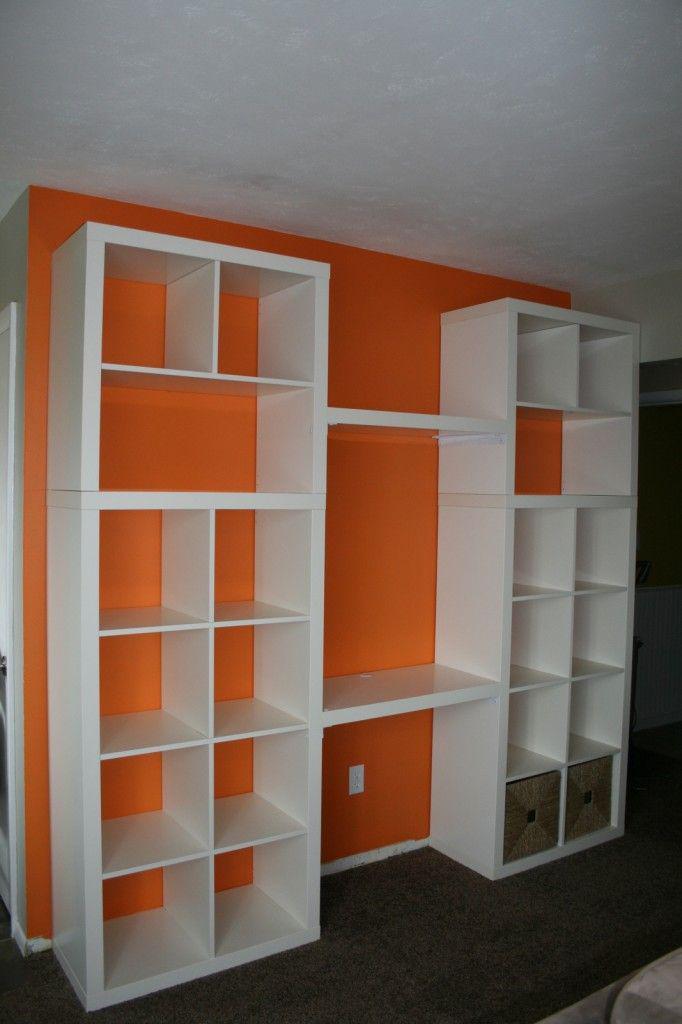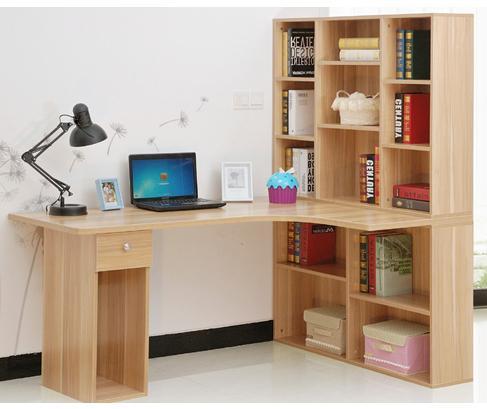The first image is the image on the left, the second image is the image on the right. Considering the images on both sides, is "A combination desk and shelf unit is built at an angle to a wall, becoming wider as it gets closer to the floor, with a small desk area in the center." valid? Answer yes or no. No. The first image is the image on the left, the second image is the image on the right. Analyze the images presented: Is the assertion "One image features an open-backed shelf with a front that angles toward a white wall like a ladder." valid? Answer yes or no. No. 